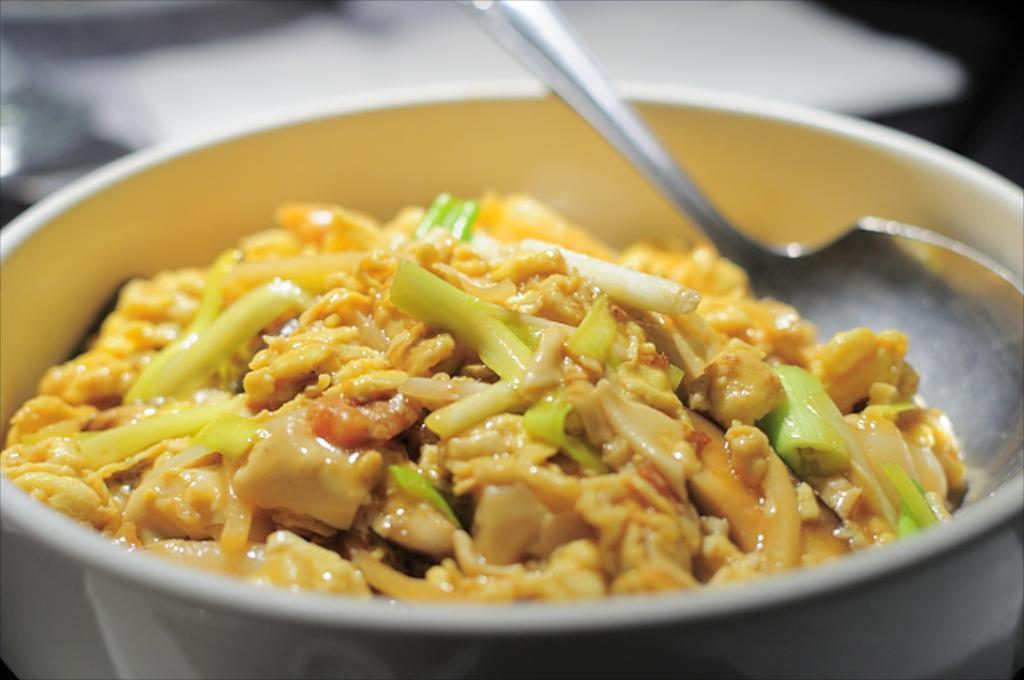What is the main food item in the image? There is a food item in a bowl in the image. What utensil is present in the image? There is a spoon in the image. What is the food item likely served on? There is a plate in the image, which is likely where the food item is served. What type of egg is being cracked in the alley in the image? There is no egg or alley present in the image; it features a food item in a bowl with a spoon and a plate. 